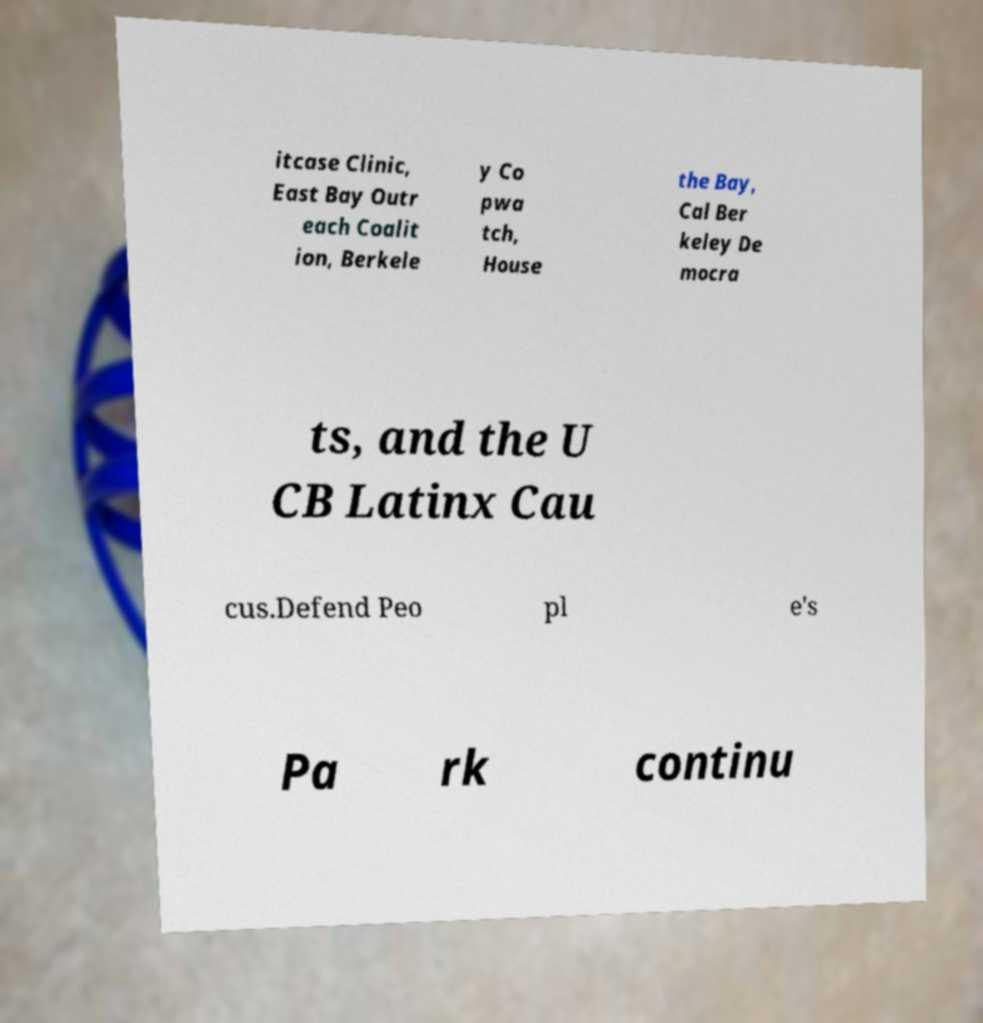There's text embedded in this image that I need extracted. Can you transcribe it verbatim? itcase Clinic, East Bay Outr each Coalit ion, Berkele y Co pwa tch, House the Bay, Cal Ber keley De mocra ts, and the U CB Latinx Cau cus.Defend Peo pl e's Pa rk continu 